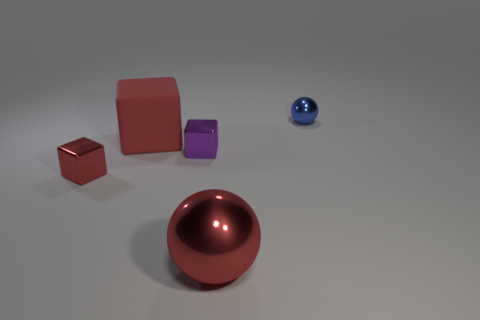Add 4 red rubber spheres. How many objects exist? 9 Subtract all cubes. How many objects are left? 2 Subtract 1 blue spheres. How many objects are left? 4 Subtract all small green blocks. Subtract all red shiny cubes. How many objects are left? 4 Add 4 big rubber things. How many big rubber things are left? 5 Add 1 big rubber blocks. How many big rubber blocks exist? 2 